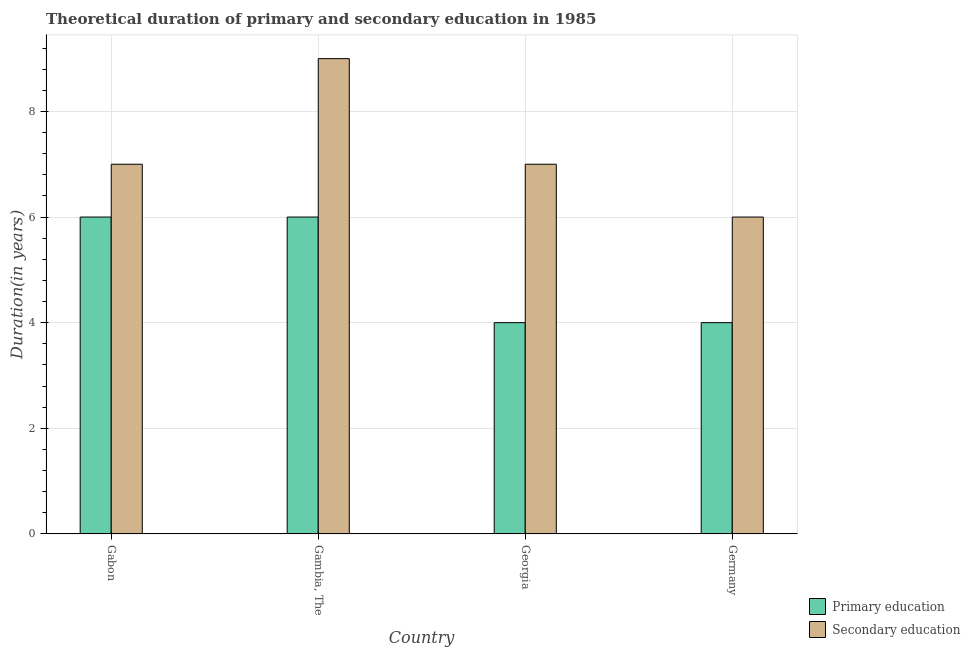How many different coloured bars are there?
Give a very brief answer. 2. Are the number of bars per tick equal to the number of legend labels?
Give a very brief answer. Yes. What is the label of the 1st group of bars from the left?
Offer a terse response. Gabon. In how many cases, is the number of bars for a given country not equal to the number of legend labels?
Your response must be concise. 0. What is the duration of secondary education in Germany?
Provide a short and direct response. 6. Across all countries, what is the maximum duration of secondary education?
Ensure brevity in your answer.  9. In which country was the duration of primary education maximum?
Your answer should be compact. Gabon. In which country was the duration of primary education minimum?
Make the answer very short. Georgia. What is the total duration of secondary education in the graph?
Ensure brevity in your answer.  29. What is the difference between the duration of primary education in Gambia, The and that in Germany?
Keep it short and to the point. 2. What is the difference between the duration of primary education in Gambia, The and the duration of secondary education in Gabon?
Your response must be concise. -1. What is the average duration of secondary education per country?
Give a very brief answer. 7.25. What is the difference between the duration of primary education and duration of secondary education in Germany?
Your answer should be very brief. -2. What is the ratio of the duration of primary education in Gabon to that in Gambia, The?
Provide a short and direct response. 1. Is the difference between the duration of primary education in Gambia, The and Germany greater than the difference between the duration of secondary education in Gambia, The and Germany?
Your answer should be compact. No. What is the difference between the highest and the lowest duration of primary education?
Offer a very short reply. 2. Is the sum of the duration of primary education in Gabon and Germany greater than the maximum duration of secondary education across all countries?
Make the answer very short. Yes. What does the 1st bar from the left in Gambia, The represents?
Provide a succinct answer. Primary education. What does the 2nd bar from the right in Gabon represents?
Offer a very short reply. Primary education. How many bars are there?
Offer a terse response. 8. Are all the bars in the graph horizontal?
Your answer should be very brief. No. How many countries are there in the graph?
Your answer should be compact. 4. Does the graph contain grids?
Your answer should be very brief. Yes. Where does the legend appear in the graph?
Offer a terse response. Bottom right. How many legend labels are there?
Provide a succinct answer. 2. What is the title of the graph?
Offer a very short reply. Theoretical duration of primary and secondary education in 1985. What is the label or title of the X-axis?
Provide a short and direct response. Country. What is the label or title of the Y-axis?
Make the answer very short. Duration(in years). What is the Duration(in years) of Primary education in Gabon?
Make the answer very short. 6. What is the Duration(in years) in Primary education in Georgia?
Give a very brief answer. 4. Across all countries, what is the minimum Duration(in years) in Primary education?
Your response must be concise. 4. What is the total Duration(in years) in Primary education in the graph?
Provide a succinct answer. 20. What is the total Duration(in years) of Secondary education in the graph?
Offer a very short reply. 29. What is the difference between the Duration(in years) of Primary education in Gabon and that in Gambia, The?
Offer a very short reply. 0. What is the difference between the Duration(in years) in Secondary education in Gabon and that in Gambia, The?
Keep it short and to the point. -2. What is the difference between the Duration(in years) of Primary education in Gabon and that in Germany?
Provide a succinct answer. 2. What is the difference between the Duration(in years) of Primary education in Gambia, The and that in Georgia?
Offer a terse response. 2. What is the difference between the Duration(in years) of Primary education in Gambia, The and that in Germany?
Give a very brief answer. 2. What is the difference between the Duration(in years) of Secondary education in Gambia, The and that in Germany?
Your answer should be compact. 3. What is the difference between the Duration(in years) of Secondary education in Georgia and that in Germany?
Provide a short and direct response. 1. What is the difference between the Duration(in years) of Primary education in Gabon and the Duration(in years) of Secondary education in Gambia, The?
Your answer should be compact. -3. What is the difference between the Duration(in years) in Primary education in Gabon and the Duration(in years) in Secondary education in Georgia?
Ensure brevity in your answer.  -1. What is the difference between the Duration(in years) of Primary education in Gambia, The and the Duration(in years) of Secondary education in Georgia?
Give a very brief answer. -1. What is the difference between the Duration(in years) of Primary education in Gambia, The and the Duration(in years) of Secondary education in Germany?
Your response must be concise. 0. What is the average Duration(in years) in Primary education per country?
Offer a terse response. 5. What is the average Duration(in years) in Secondary education per country?
Ensure brevity in your answer.  7.25. What is the difference between the Duration(in years) in Primary education and Duration(in years) in Secondary education in Gabon?
Provide a short and direct response. -1. What is the difference between the Duration(in years) of Primary education and Duration(in years) of Secondary education in Georgia?
Keep it short and to the point. -3. What is the ratio of the Duration(in years) in Primary education in Gabon to that in Gambia, The?
Ensure brevity in your answer.  1. What is the ratio of the Duration(in years) of Primary education in Gabon to that in Georgia?
Give a very brief answer. 1.5. What is the ratio of the Duration(in years) of Secondary education in Gabon to that in Georgia?
Provide a short and direct response. 1. What is the ratio of the Duration(in years) of Primary education in Gambia, The to that in Georgia?
Provide a succinct answer. 1.5. What is the ratio of the Duration(in years) in Primary education in Gambia, The to that in Germany?
Offer a very short reply. 1.5. What is the ratio of the Duration(in years) of Secondary education in Gambia, The to that in Germany?
Ensure brevity in your answer.  1.5. What is the ratio of the Duration(in years) of Primary education in Georgia to that in Germany?
Offer a very short reply. 1. What is the difference between the highest and the second highest Duration(in years) in Primary education?
Keep it short and to the point. 0. 